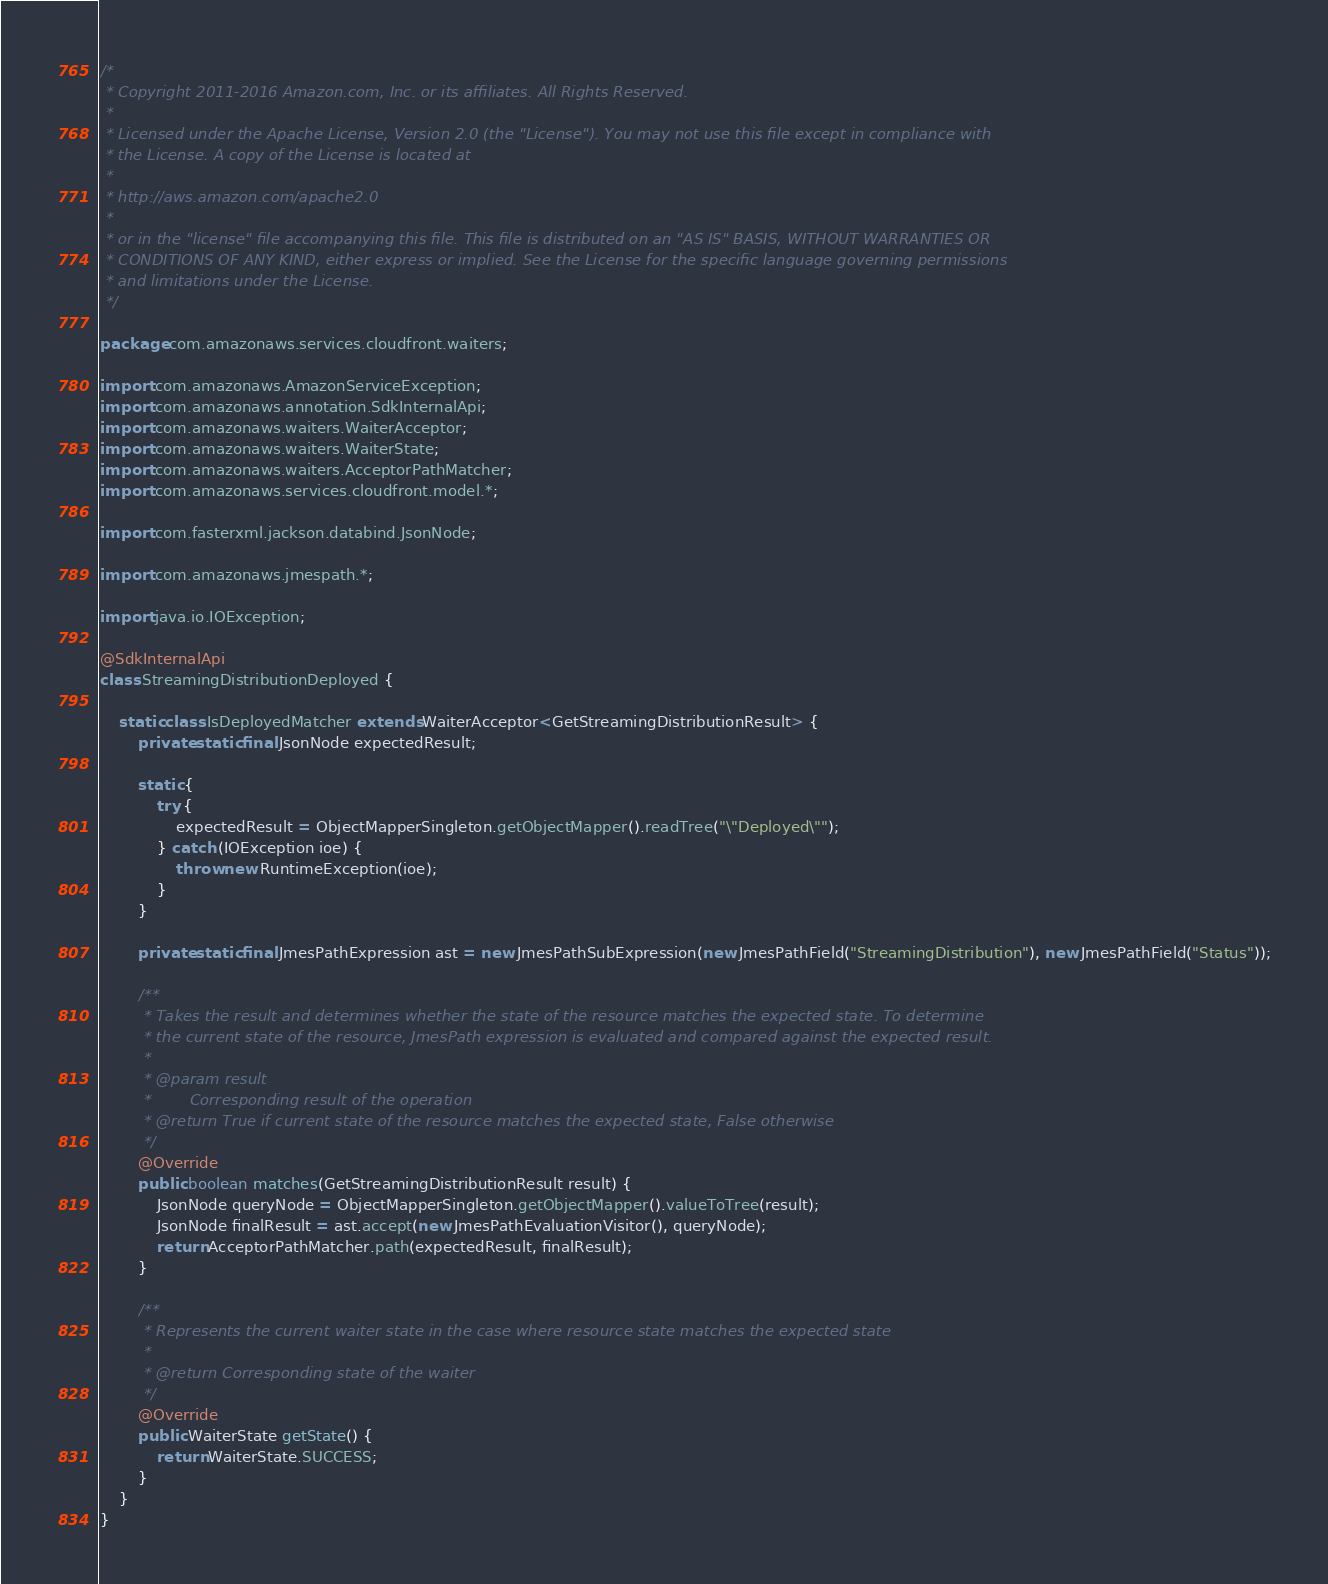Convert code to text. <code><loc_0><loc_0><loc_500><loc_500><_Java_>/*
 * Copyright 2011-2016 Amazon.com, Inc. or its affiliates. All Rights Reserved.
 * 
 * Licensed under the Apache License, Version 2.0 (the "License"). You may not use this file except in compliance with
 * the License. A copy of the License is located at
 * 
 * http://aws.amazon.com/apache2.0
 * 
 * or in the "license" file accompanying this file. This file is distributed on an "AS IS" BASIS, WITHOUT WARRANTIES OR
 * CONDITIONS OF ANY KIND, either express or implied. See the License for the specific language governing permissions
 * and limitations under the License.
 */

package com.amazonaws.services.cloudfront.waiters;

import com.amazonaws.AmazonServiceException;
import com.amazonaws.annotation.SdkInternalApi;
import com.amazonaws.waiters.WaiterAcceptor;
import com.amazonaws.waiters.WaiterState;
import com.amazonaws.waiters.AcceptorPathMatcher;
import com.amazonaws.services.cloudfront.model.*;

import com.fasterxml.jackson.databind.JsonNode;

import com.amazonaws.jmespath.*;

import java.io.IOException;

@SdkInternalApi
class StreamingDistributionDeployed {

    static class IsDeployedMatcher extends WaiterAcceptor<GetStreamingDistributionResult> {
        private static final JsonNode expectedResult;

        static {
            try {
                expectedResult = ObjectMapperSingleton.getObjectMapper().readTree("\"Deployed\"");
            } catch (IOException ioe) {
                throw new RuntimeException(ioe);
            }
        }

        private static final JmesPathExpression ast = new JmesPathSubExpression(new JmesPathField("StreamingDistribution"), new JmesPathField("Status"));

        /**
         * Takes the result and determines whether the state of the resource matches the expected state. To determine
         * the current state of the resource, JmesPath expression is evaluated and compared against the expected result.
         * 
         * @param result
         *        Corresponding result of the operation
         * @return True if current state of the resource matches the expected state, False otherwise
         */
        @Override
        public boolean matches(GetStreamingDistributionResult result) {
            JsonNode queryNode = ObjectMapperSingleton.getObjectMapper().valueToTree(result);
            JsonNode finalResult = ast.accept(new JmesPathEvaluationVisitor(), queryNode);
            return AcceptorPathMatcher.path(expectedResult, finalResult);
        }

        /**
         * Represents the current waiter state in the case where resource state matches the expected state
         * 
         * @return Corresponding state of the waiter
         */
        @Override
        public WaiterState getState() {
            return WaiterState.SUCCESS;
        }
    }
}
</code> 